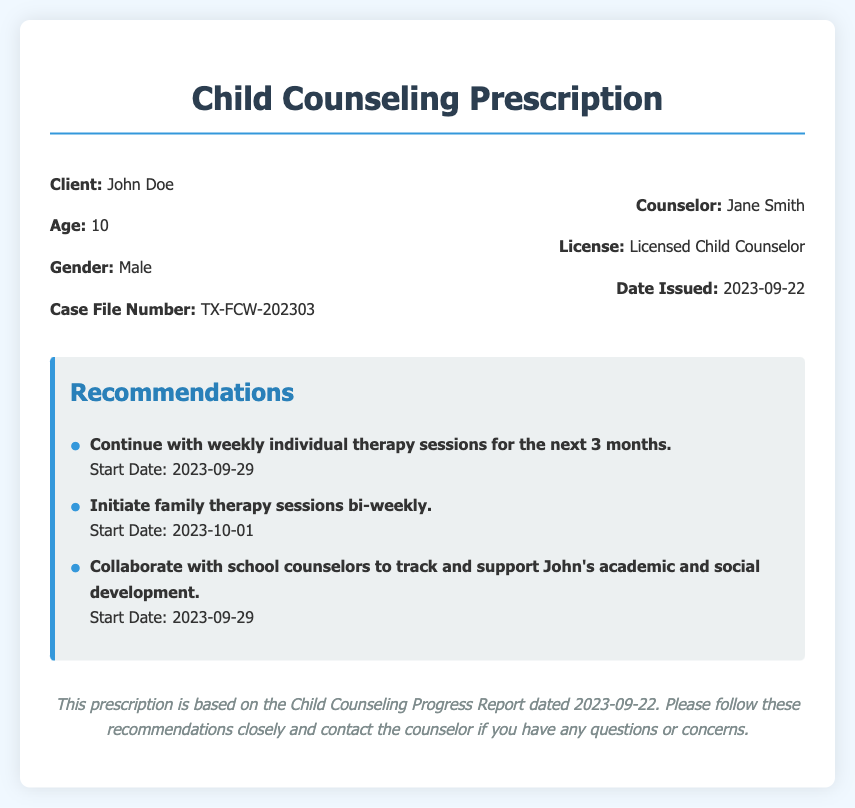What is the client's name? The client's name is mentioned at the beginning of the document in the client information section.
Answer: John Doe What is the client's age? The age of the client is provided in the same section as the name, specifically stating the age of the child.
Answer: 10 What is the case file number? The case file number is specified in the client information section and is a unique identifier for the client's file.
Answer: TX-FCW-202303 When is the start date for weekly individual therapy sessions? The start date for weekly individual therapy sessions is listed under the recommendations section of the document.
Answer: 2023-09-29 How often will family therapy sessions occur? The frequency of family therapy sessions is stated in the recommendations section of the document.
Answer: Bi-weekly Who is the counselor's name? The name of the counselor is provided in the counselor information section at the top of the document.
Answer: Jane Smith What is the date the report was issued? The date the report was issued is mentioned in the counselor information section.
Answer: 2023-09-22 What is the main purpose of this document? This document provides recommendations for counseling based on a progress report, indicating its nature and focus.
Answer: Counseling Prescription How should school counselors be involved in John's progress? The document states how collaboration with school counselors should be handled, highlighting the importance of their role.
Answer: Track and support academic and social development 